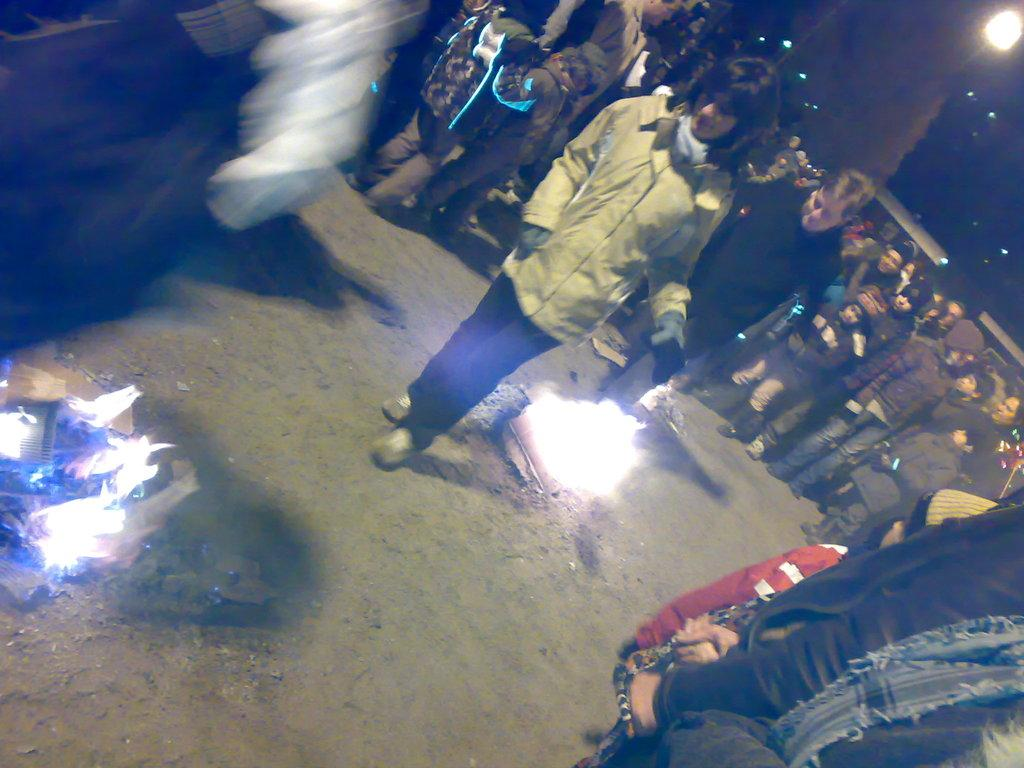What are the persons in the image doing? The persons in the image are walking through fire. Are there any other people present in the image? Yes, there are people around them in the image. What type of tub can be seen in the image? There is no tub present in the image. How does the fire taste in the image? The fire in the image is not something that can be tasted, as it is a visual representation and not a physical sensation. 